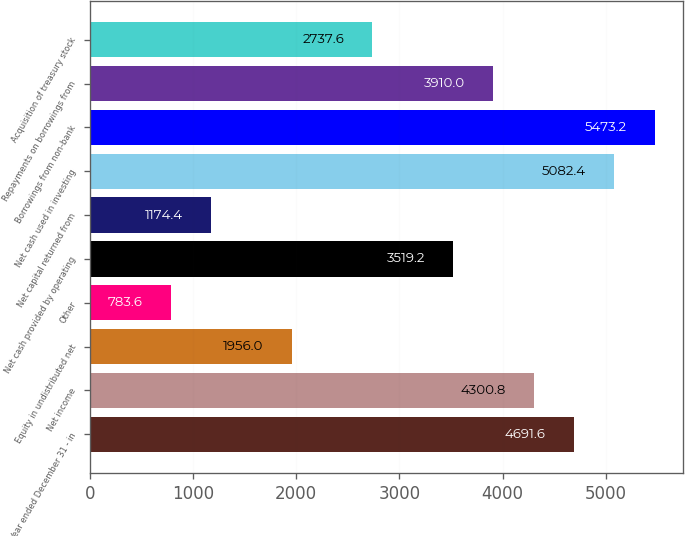Convert chart to OTSL. <chart><loc_0><loc_0><loc_500><loc_500><bar_chart><fcel>Year ended December 31 - in<fcel>Net income<fcel>Equity in undistributed net<fcel>Other<fcel>Net cash provided by operating<fcel>Net capital returned from<fcel>Net cash used in investing<fcel>Borrowings from non-bank<fcel>Repayments on borrowings from<fcel>Acquisition of treasury stock<nl><fcel>4691.6<fcel>4300.8<fcel>1956<fcel>783.6<fcel>3519.2<fcel>1174.4<fcel>5082.4<fcel>5473.2<fcel>3910<fcel>2737.6<nl></chart> 